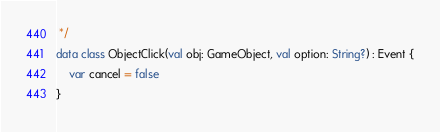<code> <loc_0><loc_0><loc_500><loc_500><_Kotlin_> */
data class ObjectClick(val obj: GameObject, val option: String?) : Event {
    var cancel = false
}</code> 